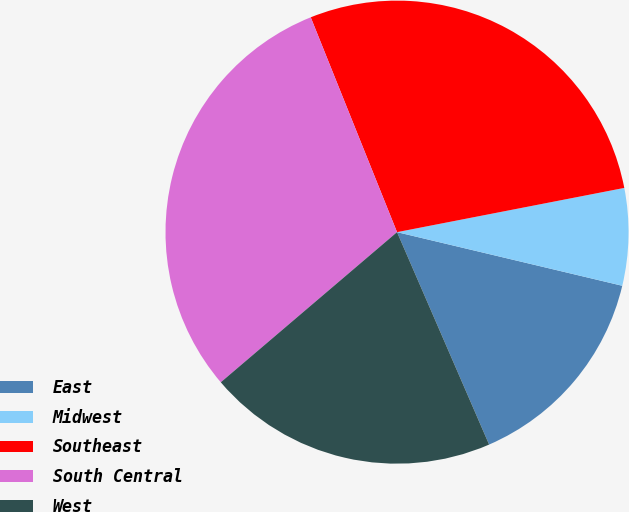Convert chart to OTSL. <chart><loc_0><loc_0><loc_500><loc_500><pie_chart><fcel>East<fcel>Midwest<fcel>Southeast<fcel>South Central<fcel>West<nl><fcel>14.77%<fcel>6.78%<fcel>28.02%<fcel>30.15%<fcel>20.28%<nl></chart> 